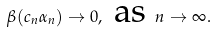<formula> <loc_0><loc_0><loc_500><loc_500>\beta ( c _ { n } \alpha _ { n } ) \rightarrow 0 , \text { as } n \rightarrow \infty .</formula> 